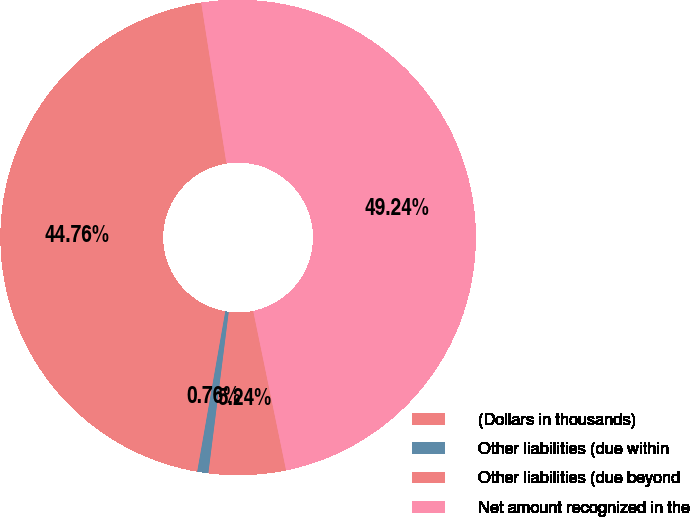<chart> <loc_0><loc_0><loc_500><loc_500><pie_chart><fcel>(Dollars in thousands)<fcel>Other liabilities (due within<fcel>Other liabilities (due beyond<fcel>Net amount recognized in the<nl><fcel>5.24%<fcel>0.76%<fcel>44.76%<fcel>49.24%<nl></chart> 